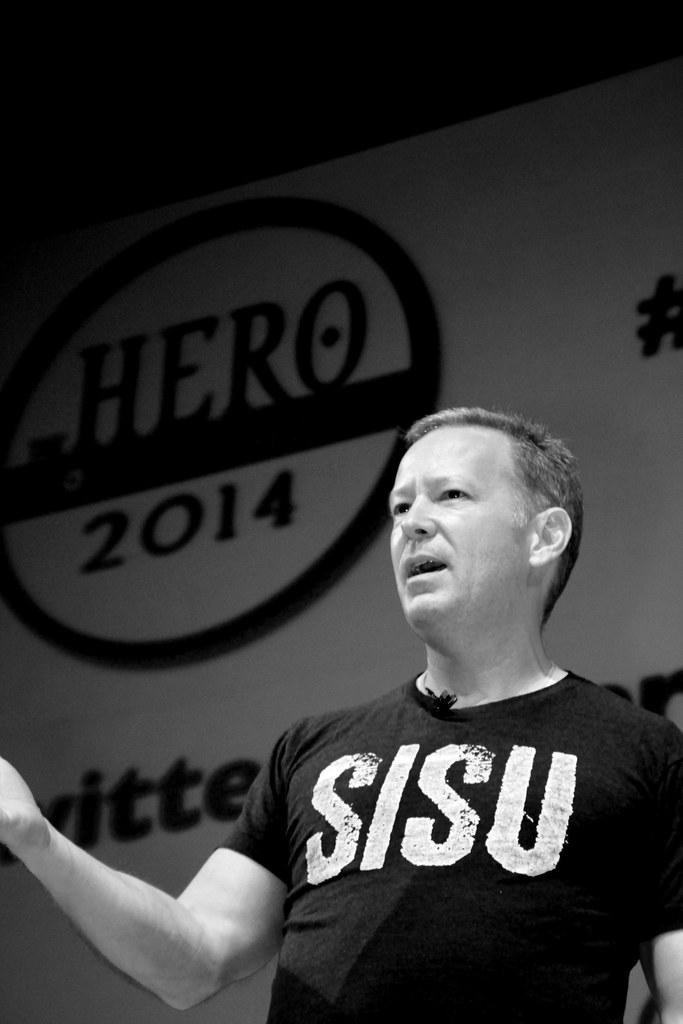<image>
Relay a brief, clear account of the picture shown. A man wearing a SISU shirt gives a speech 